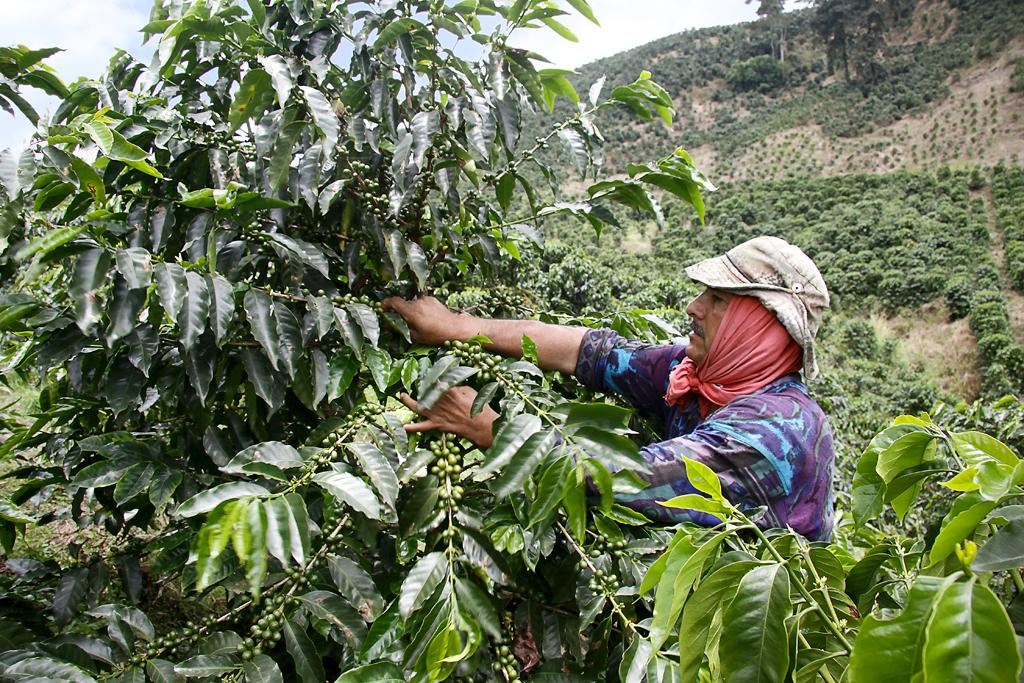What type of plant is present in the image? There is a tree with leaves and fruits in the image. Can you describe the person in the image? There is a man with a cap in the image. What is the man doing in the image? The man is touching the tree. What can be seen in the background of the image? There is a hill with many trees and the sky visible in the background of the image. What level of surprise is the man expressing in the image? There is no indication of the man's level of surprise in the image; he is simply touching the tree. Where is the middle of the image located? The concept of a "middle" of the image is not applicable in this context, as it refers to a spatial location within the image. The image is a two-dimensional representation and does not have a middle in the same way a physical space does. 